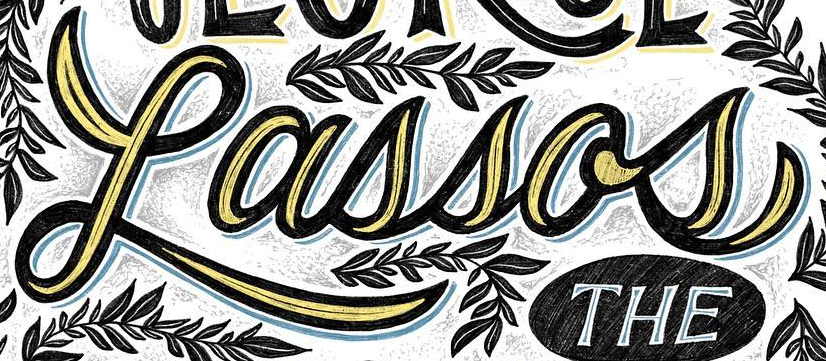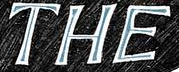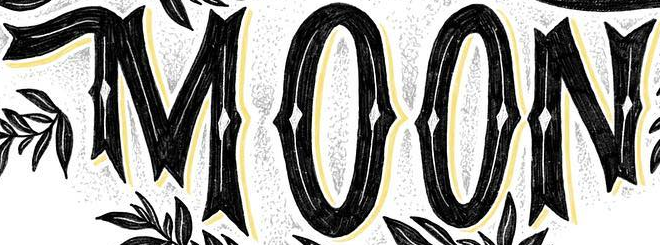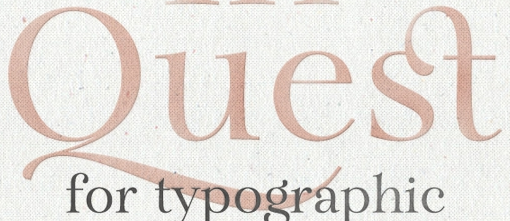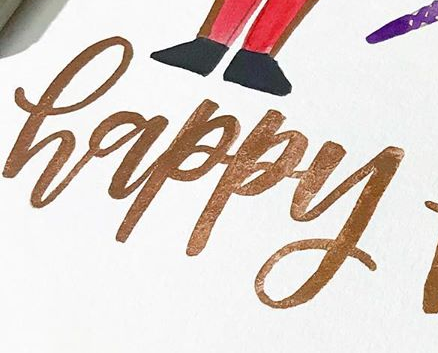Identify the words shown in these images in order, separated by a semicolon. Lassos; THE; MOON; Quest; happy 